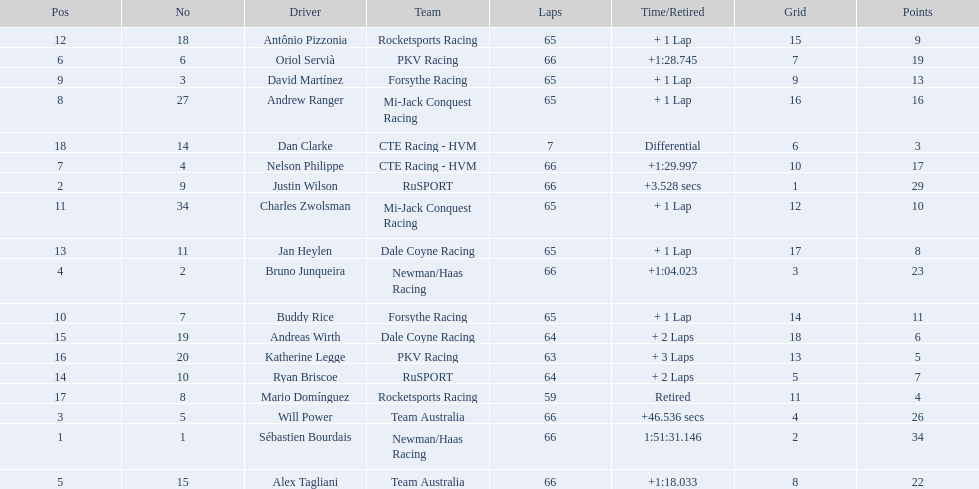How many points did first place receive? 34. How many did last place receive? 3. Who was the recipient of these last place points? Dan Clarke. 